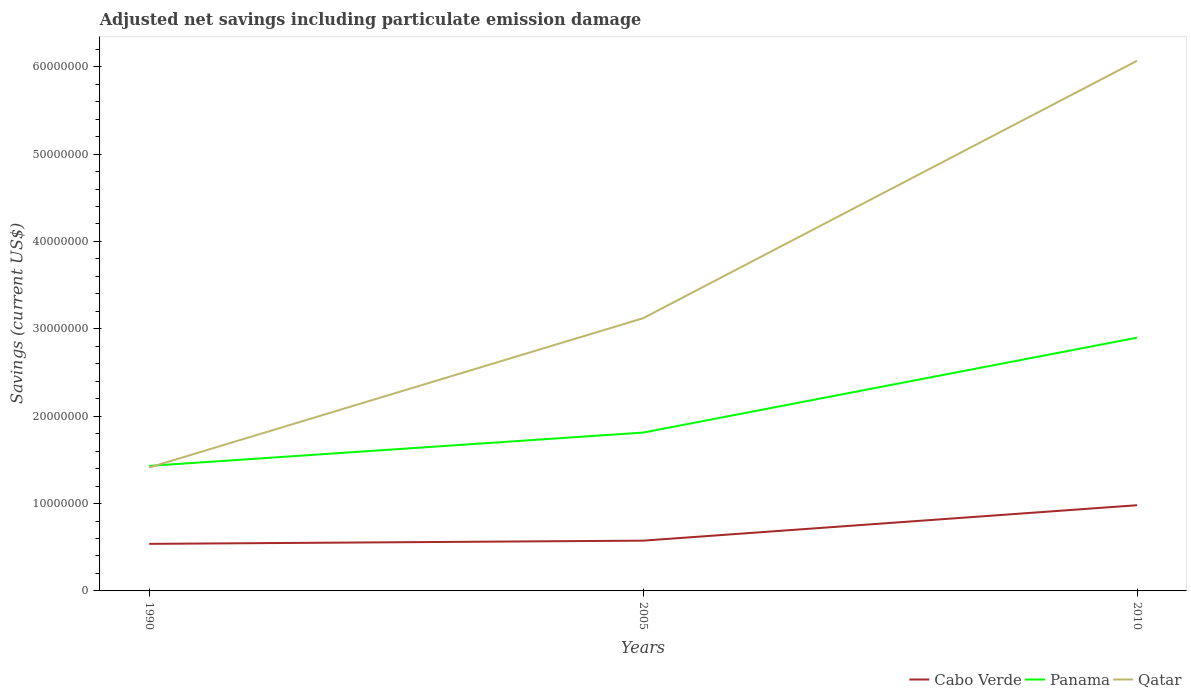Is the number of lines equal to the number of legend labels?
Offer a terse response. Yes. Across all years, what is the maximum net savings in Qatar?
Your answer should be compact. 1.41e+07. What is the total net savings in Qatar in the graph?
Your answer should be compact. -1.71e+07. What is the difference between the highest and the second highest net savings in Panama?
Offer a terse response. 1.47e+07. What is the difference between the highest and the lowest net savings in Qatar?
Give a very brief answer. 1. Does the graph contain any zero values?
Provide a succinct answer. No. Where does the legend appear in the graph?
Offer a very short reply. Bottom right. How many legend labels are there?
Your answer should be compact. 3. How are the legend labels stacked?
Provide a succinct answer. Horizontal. What is the title of the graph?
Provide a short and direct response. Adjusted net savings including particulate emission damage. Does "Jamaica" appear as one of the legend labels in the graph?
Your answer should be compact. No. What is the label or title of the X-axis?
Keep it short and to the point. Years. What is the label or title of the Y-axis?
Your answer should be compact. Savings (current US$). What is the Savings (current US$) of Cabo Verde in 1990?
Give a very brief answer. 5.39e+06. What is the Savings (current US$) of Panama in 1990?
Your answer should be compact. 1.43e+07. What is the Savings (current US$) of Qatar in 1990?
Keep it short and to the point. 1.41e+07. What is the Savings (current US$) of Cabo Verde in 2005?
Offer a terse response. 5.75e+06. What is the Savings (current US$) in Panama in 2005?
Provide a short and direct response. 1.81e+07. What is the Savings (current US$) of Qatar in 2005?
Keep it short and to the point. 3.12e+07. What is the Savings (current US$) of Cabo Verde in 2010?
Keep it short and to the point. 9.81e+06. What is the Savings (current US$) in Panama in 2010?
Give a very brief answer. 2.90e+07. What is the Savings (current US$) of Qatar in 2010?
Ensure brevity in your answer.  6.07e+07. Across all years, what is the maximum Savings (current US$) in Cabo Verde?
Keep it short and to the point. 9.81e+06. Across all years, what is the maximum Savings (current US$) in Panama?
Your answer should be compact. 2.90e+07. Across all years, what is the maximum Savings (current US$) of Qatar?
Your response must be concise. 6.07e+07. Across all years, what is the minimum Savings (current US$) in Cabo Verde?
Your answer should be compact. 5.39e+06. Across all years, what is the minimum Savings (current US$) in Panama?
Your answer should be very brief. 1.43e+07. Across all years, what is the minimum Savings (current US$) of Qatar?
Keep it short and to the point. 1.41e+07. What is the total Savings (current US$) of Cabo Verde in the graph?
Offer a terse response. 2.10e+07. What is the total Savings (current US$) in Panama in the graph?
Your response must be concise. 6.14e+07. What is the total Savings (current US$) of Qatar in the graph?
Your answer should be very brief. 1.06e+08. What is the difference between the Savings (current US$) of Cabo Verde in 1990 and that in 2005?
Provide a succinct answer. -3.66e+05. What is the difference between the Savings (current US$) of Panama in 1990 and that in 2005?
Offer a very short reply. -3.82e+06. What is the difference between the Savings (current US$) in Qatar in 1990 and that in 2005?
Keep it short and to the point. -1.71e+07. What is the difference between the Savings (current US$) of Cabo Verde in 1990 and that in 2010?
Give a very brief answer. -4.42e+06. What is the difference between the Savings (current US$) in Panama in 1990 and that in 2010?
Your response must be concise. -1.47e+07. What is the difference between the Savings (current US$) in Qatar in 1990 and that in 2010?
Ensure brevity in your answer.  -4.66e+07. What is the difference between the Savings (current US$) of Cabo Verde in 2005 and that in 2010?
Offer a very short reply. -4.06e+06. What is the difference between the Savings (current US$) of Panama in 2005 and that in 2010?
Keep it short and to the point. -1.09e+07. What is the difference between the Savings (current US$) of Qatar in 2005 and that in 2010?
Your answer should be very brief. -2.95e+07. What is the difference between the Savings (current US$) of Cabo Verde in 1990 and the Savings (current US$) of Panama in 2005?
Your answer should be very brief. -1.27e+07. What is the difference between the Savings (current US$) of Cabo Verde in 1990 and the Savings (current US$) of Qatar in 2005?
Provide a short and direct response. -2.58e+07. What is the difference between the Savings (current US$) of Panama in 1990 and the Savings (current US$) of Qatar in 2005?
Give a very brief answer. -1.69e+07. What is the difference between the Savings (current US$) of Cabo Verde in 1990 and the Savings (current US$) of Panama in 2010?
Ensure brevity in your answer.  -2.36e+07. What is the difference between the Savings (current US$) of Cabo Verde in 1990 and the Savings (current US$) of Qatar in 2010?
Give a very brief answer. -5.53e+07. What is the difference between the Savings (current US$) in Panama in 1990 and the Savings (current US$) in Qatar in 2010?
Provide a succinct answer. -4.64e+07. What is the difference between the Savings (current US$) of Cabo Verde in 2005 and the Savings (current US$) of Panama in 2010?
Your answer should be compact. -2.32e+07. What is the difference between the Savings (current US$) of Cabo Verde in 2005 and the Savings (current US$) of Qatar in 2010?
Your response must be concise. -5.49e+07. What is the difference between the Savings (current US$) in Panama in 2005 and the Savings (current US$) in Qatar in 2010?
Your answer should be very brief. -4.26e+07. What is the average Savings (current US$) of Cabo Verde per year?
Give a very brief answer. 6.98e+06. What is the average Savings (current US$) in Panama per year?
Provide a short and direct response. 2.05e+07. What is the average Savings (current US$) of Qatar per year?
Give a very brief answer. 3.53e+07. In the year 1990, what is the difference between the Savings (current US$) in Cabo Verde and Savings (current US$) in Panama?
Offer a terse response. -8.92e+06. In the year 1990, what is the difference between the Savings (current US$) in Cabo Verde and Savings (current US$) in Qatar?
Provide a short and direct response. -8.74e+06. In the year 1990, what is the difference between the Savings (current US$) in Panama and Savings (current US$) in Qatar?
Offer a terse response. 1.85e+05. In the year 2005, what is the difference between the Savings (current US$) of Cabo Verde and Savings (current US$) of Panama?
Give a very brief answer. -1.24e+07. In the year 2005, what is the difference between the Savings (current US$) in Cabo Verde and Savings (current US$) in Qatar?
Your answer should be very brief. -2.55e+07. In the year 2005, what is the difference between the Savings (current US$) in Panama and Savings (current US$) in Qatar?
Keep it short and to the point. -1.31e+07. In the year 2010, what is the difference between the Savings (current US$) in Cabo Verde and Savings (current US$) in Panama?
Make the answer very short. -1.92e+07. In the year 2010, what is the difference between the Savings (current US$) of Cabo Verde and Savings (current US$) of Qatar?
Ensure brevity in your answer.  -5.09e+07. In the year 2010, what is the difference between the Savings (current US$) in Panama and Savings (current US$) in Qatar?
Your response must be concise. -3.17e+07. What is the ratio of the Savings (current US$) of Cabo Verde in 1990 to that in 2005?
Offer a terse response. 0.94. What is the ratio of the Savings (current US$) in Panama in 1990 to that in 2005?
Provide a short and direct response. 0.79. What is the ratio of the Savings (current US$) in Qatar in 1990 to that in 2005?
Ensure brevity in your answer.  0.45. What is the ratio of the Savings (current US$) in Cabo Verde in 1990 to that in 2010?
Your response must be concise. 0.55. What is the ratio of the Savings (current US$) of Panama in 1990 to that in 2010?
Your answer should be compact. 0.49. What is the ratio of the Savings (current US$) in Qatar in 1990 to that in 2010?
Make the answer very short. 0.23. What is the ratio of the Savings (current US$) in Cabo Verde in 2005 to that in 2010?
Your response must be concise. 0.59. What is the ratio of the Savings (current US$) in Panama in 2005 to that in 2010?
Give a very brief answer. 0.63. What is the ratio of the Savings (current US$) of Qatar in 2005 to that in 2010?
Your answer should be very brief. 0.51. What is the difference between the highest and the second highest Savings (current US$) of Cabo Verde?
Your answer should be compact. 4.06e+06. What is the difference between the highest and the second highest Savings (current US$) in Panama?
Keep it short and to the point. 1.09e+07. What is the difference between the highest and the second highest Savings (current US$) of Qatar?
Your answer should be very brief. 2.95e+07. What is the difference between the highest and the lowest Savings (current US$) in Cabo Verde?
Provide a succinct answer. 4.42e+06. What is the difference between the highest and the lowest Savings (current US$) of Panama?
Give a very brief answer. 1.47e+07. What is the difference between the highest and the lowest Savings (current US$) in Qatar?
Your response must be concise. 4.66e+07. 